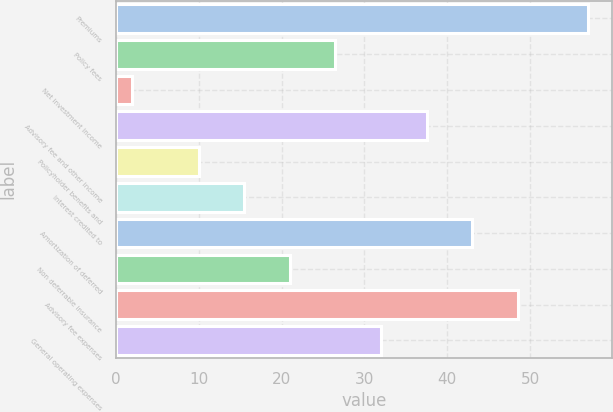<chart> <loc_0><loc_0><loc_500><loc_500><bar_chart><fcel>Premiums<fcel>Policy fees<fcel>Net investment income<fcel>Advisory fee and other income<fcel>Policyholder benefits and<fcel>Interest credited to<fcel>Amortization of deferred<fcel>Non deferrable insurance<fcel>Advisory fee expenses<fcel>General operating expenses<nl><fcel>57<fcel>26.5<fcel>2<fcel>37.5<fcel>10<fcel>15.5<fcel>43<fcel>21<fcel>48.5<fcel>32<nl></chart> 